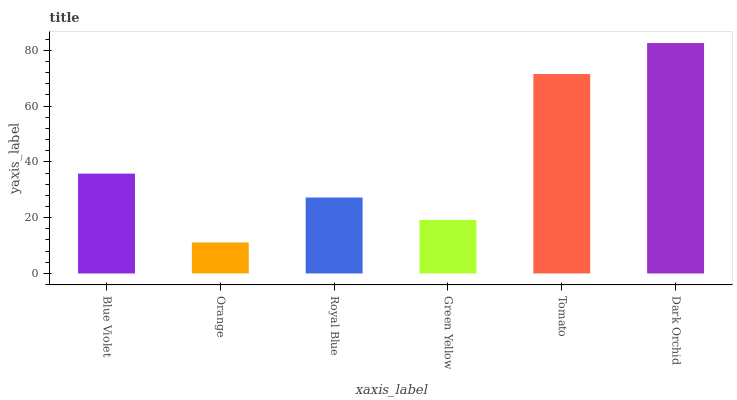Is Royal Blue the minimum?
Answer yes or no. No. Is Royal Blue the maximum?
Answer yes or no. No. Is Royal Blue greater than Orange?
Answer yes or no. Yes. Is Orange less than Royal Blue?
Answer yes or no. Yes. Is Orange greater than Royal Blue?
Answer yes or no. No. Is Royal Blue less than Orange?
Answer yes or no. No. Is Blue Violet the high median?
Answer yes or no. Yes. Is Royal Blue the low median?
Answer yes or no. Yes. Is Green Yellow the high median?
Answer yes or no. No. Is Dark Orchid the low median?
Answer yes or no. No. 